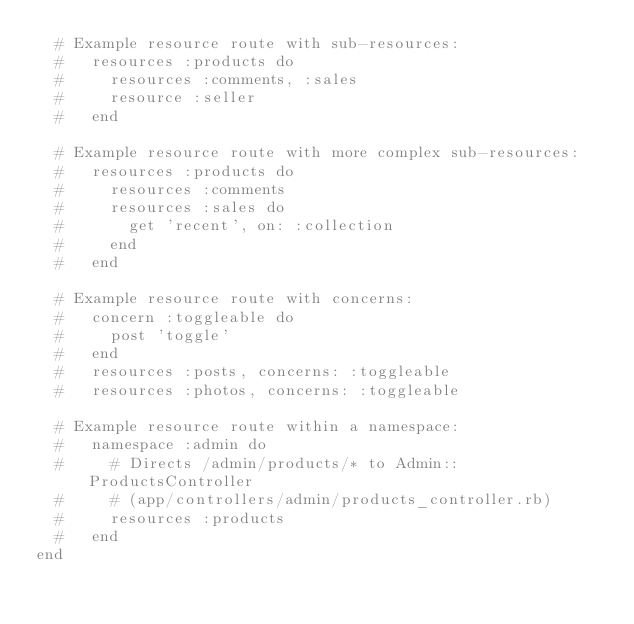<code> <loc_0><loc_0><loc_500><loc_500><_Ruby_>  # Example resource route with sub-resources:
  #   resources :products do
  #     resources :comments, :sales
  #     resource :seller
  #   end

  # Example resource route with more complex sub-resources:
  #   resources :products do
  #     resources :comments
  #     resources :sales do
  #       get 'recent', on: :collection
  #     end
  #   end

  # Example resource route with concerns:
  #   concern :toggleable do
  #     post 'toggle'
  #   end
  #   resources :posts, concerns: :toggleable
  #   resources :photos, concerns: :toggleable

  # Example resource route within a namespace:
  #   namespace :admin do
  #     # Directs /admin/products/* to Admin::ProductsController
  #     # (app/controllers/admin/products_controller.rb)
  #     resources :products
  #   end
end
</code> 